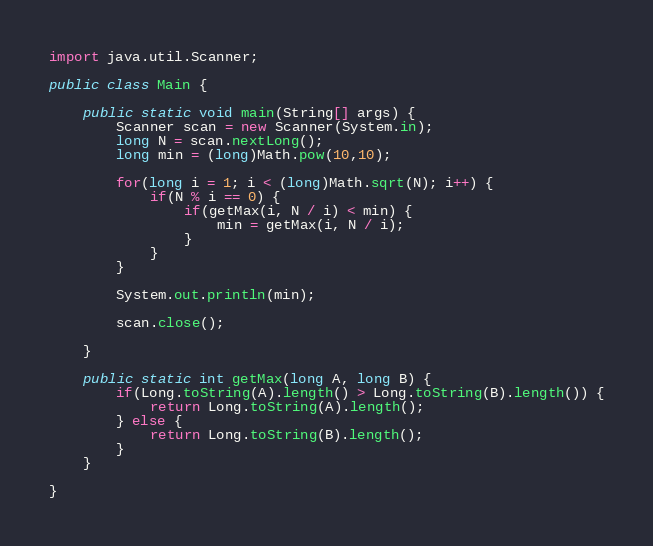Convert code to text. <code><loc_0><loc_0><loc_500><loc_500><_Java_>
import java.util.Scanner;

public class Main {

	public static void main(String[] args) {
		Scanner scan = new Scanner(System.in);
		long N = scan.nextLong();
		long min = (long)Math.pow(10,10);
		
		for(long i = 1; i < (long)Math.sqrt(N); i++) {
			if(N % i == 0) {
				if(getMax(i, N / i) < min) {
					min = getMax(i, N / i);
				}
			}
		}
		
		System.out.println(min);
		
		scan.close();

	}
	
	public static int getMax(long A, long B) {
		if(Long.toString(A).length() > Long.toString(B).length()) {
			return Long.toString(A).length();
		} else {
			return Long.toString(B).length();
		}
	}

}
</code> 